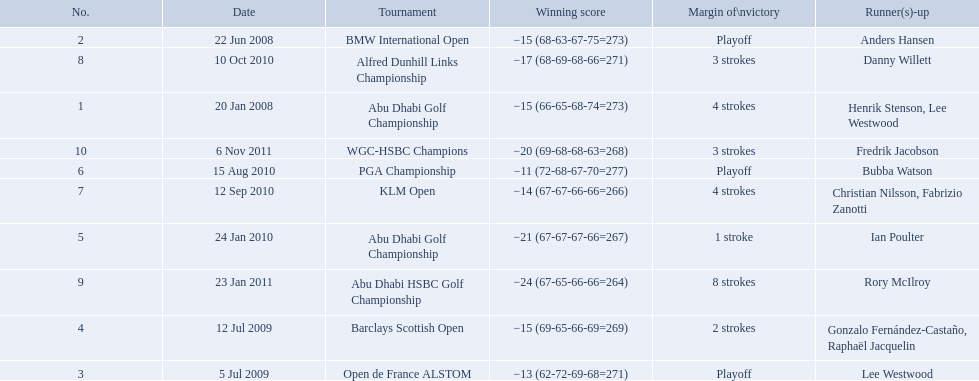Which tournaments did martin kaymer participate in? Abu Dhabi Golf Championship, BMW International Open, Open de France ALSTOM, Barclays Scottish Open, Abu Dhabi Golf Championship, PGA Championship, KLM Open, Alfred Dunhill Links Championship, Abu Dhabi HSBC Golf Championship, WGC-HSBC Champions. How many of these tournaments were won through a playoff? BMW International Open, Open de France ALSTOM, PGA Championship. Which of those tournaments took place in 2010? PGA Championship. Who had to top score next to martin kaymer for that tournament? Bubba Watson. 